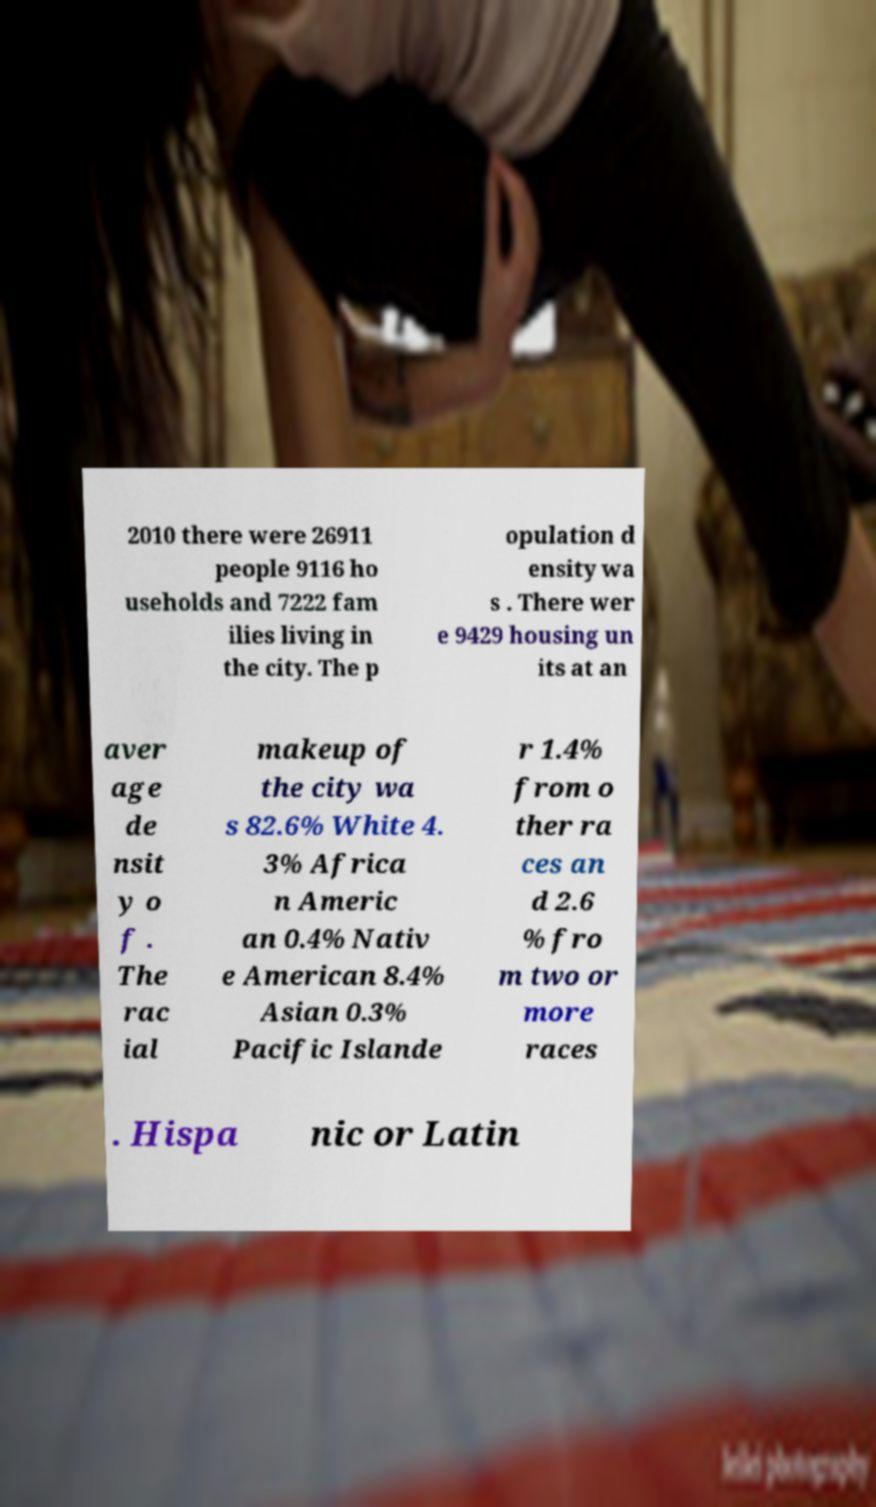Could you extract and type out the text from this image? 2010 there were 26911 people 9116 ho useholds and 7222 fam ilies living in the city. The p opulation d ensity wa s . There wer e 9429 housing un its at an aver age de nsit y o f . The rac ial makeup of the city wa s 82.6% White 4. 3% Africa n Americ an 0.4% Nativ e American 8.4% Asian 0.3% Pacific Islande r 1.4% from o ther ra ces an d 2.6 % fro m two or more races . Hispa nic or Latin 